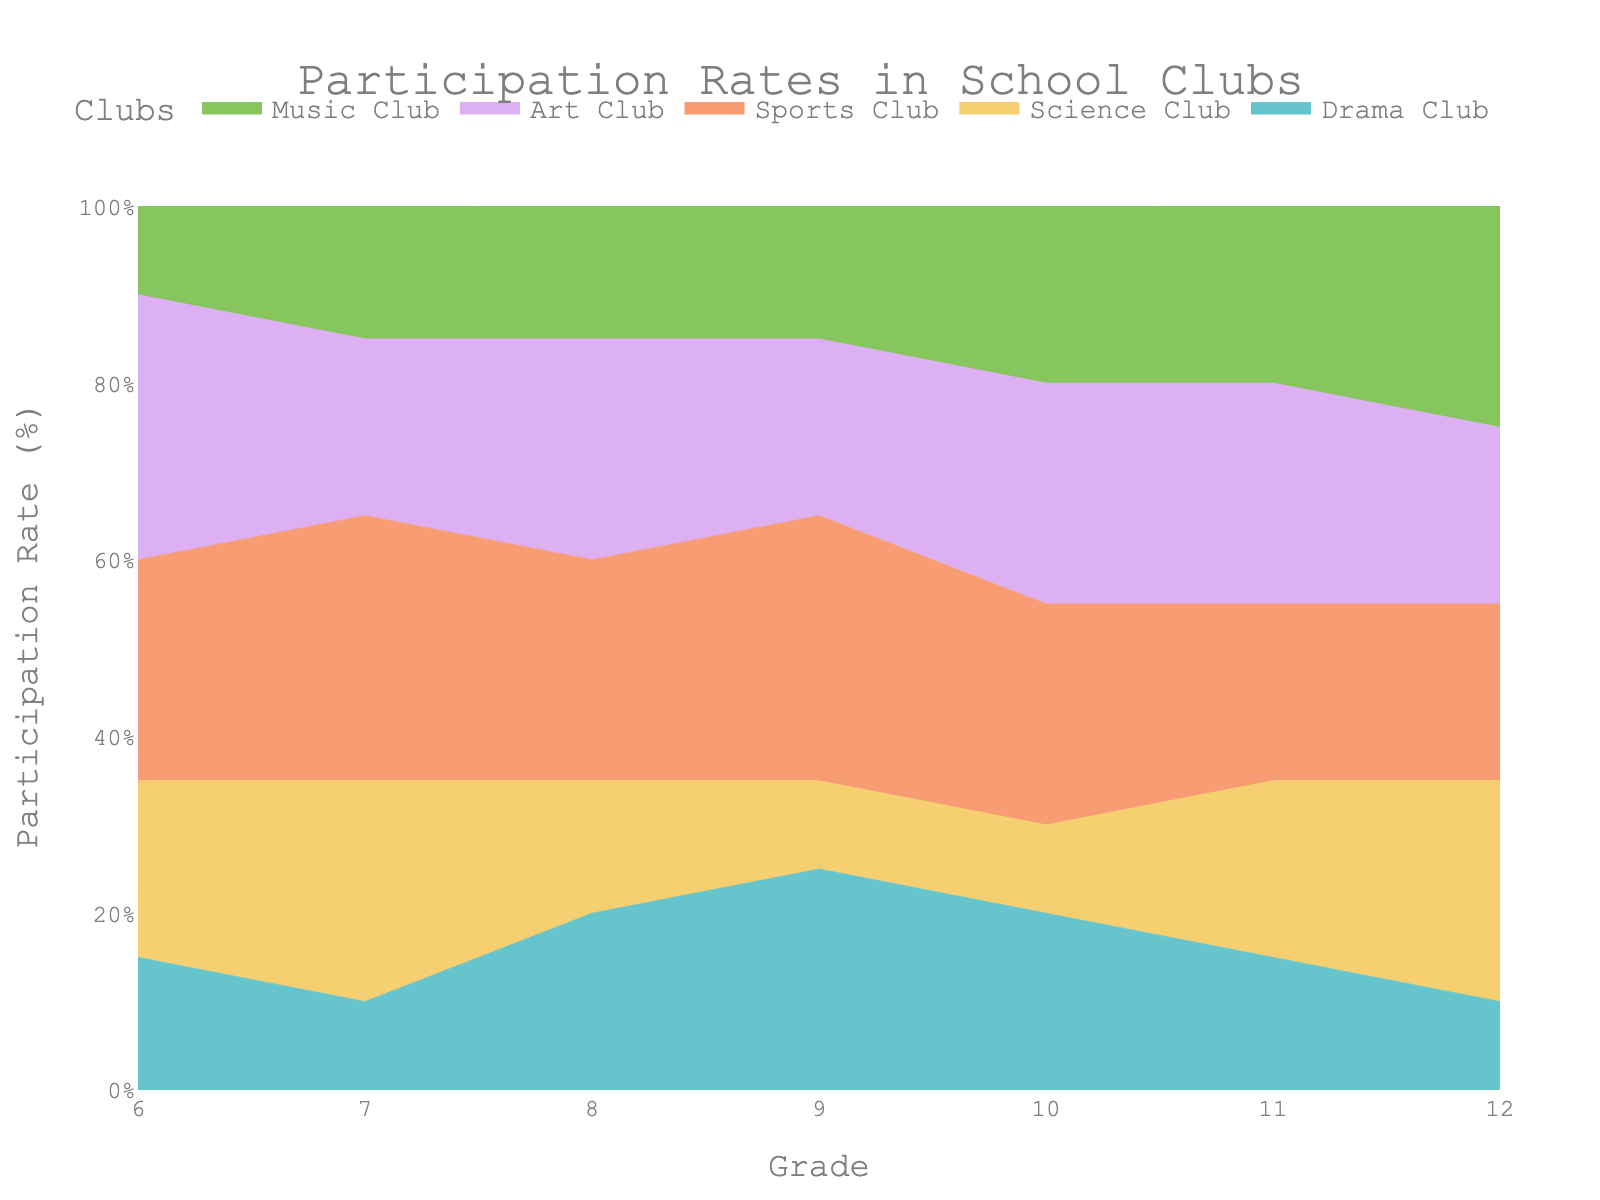What's the title of the chart? The chart's title is positioned at the top, centered and written in larger font size. According to the given data, the title mentioned in the code is "Participation Rates in School Clubs".
Answer: Participation Rates in School Clubs Which grade has the highest participation rate in the Drama Club? By looking at the colors representing the Drama Club across the grades, the highest point on the y-axis for the Drama Club is observed around the 9th grade.
Answer: 9th Grade How does the participation rate in the Science Club for grade 11 compare to grade 6? By examining the Science Club rates for both grades, we see that participation is higher in grade 11 than in grade 6. Grade 6 has 20%, whereas grade 11 has 25%.
Answer: Grade 11 has a higher participation rate In which grade does the Music Club have the maximum participation rate? By identifying the color associated with the Music Club and tracing it across the grades, it peaks in grade 12.
Answer: 12th Grade What trend can be observed in the Sports Club's participation rates from grade 6 to grade 12? By looking at the area representing the Sports Club across different grades, the participation rate starts increasing, peaks at grade 9, and then slightly drops but remains relatively high through grade 12.
Answer: Peak in grade 9, relatively high throughout If we sum the participation rates of all clubs in grade 10, what's the total percentage? In a 100% Stacked Area Chart, the total participation rate across all clubs at any grade level will sum to 100%.
Answer: 100% What is the average participation rate of the Art Club across all grades? Summing up the participation rates for the Art Club (30, 20, 25, 20, 25, 25, 20) and dividing by the number of grades (7) gives an average: (30+20+25+20+25+25+20)/7 ≈ 23.57%.
Answer: 23.57% Which club has the lowest participation rate in grade 8? Checking the values for grade 8, the Science Club has the lowest rate at 15%.
Answer: Science Club How does the participation rate in the Drama Club change from grade 6 to grade 12? By tracing the color for the Drama Club, we notice it fluctuates: it starts at 15% in grade 6, drops, peaks at grade 9, then drops again to 10% by grade 12.
Answer: Fluctuates, peaks at grade 9, drops by grade 12 Between grade levels, which grade shows a significant drop in participation rate for the Science Club when compared to its previous grade? Comparing the Science Club participation rates, there’s a significant drop from grade 7 (25%) to grade 8 (15%), and another drop from grade 6 (20%) to grade 7 (10%). However, the most significant drop is from grade 7 to grade 8.
Answer: Grade 8 